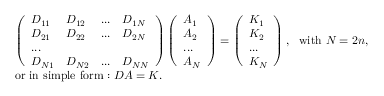<formula> <loc_0><loc_0><loc_500><loc_500>\begin{array} { r l } & { \left ( \begin{array} { l l l l } { D _ { 1 1 } } & { D _ { 1 2 } } & { \dots } & { D _ { 1 N } } \\ { D _ { 2 1 } } & { D _ { 2 2 } } & { \dots } & { D _ { 2 N } } \\ { \dots } \\ { D _ { N 1 } } & { D _ { N 2 } } & { \dots } & { D _ { N N } } \end{array} \right ) \left ( \begin{array} { l } { A _ { 1 } } \\ { A _ { 2 } } \\ { \dots } \\ { A _ { N } } \end{array} \right ) = \left ( \begin{array} { l } { K _ { 1 } } \\ { K _ { 2 } } \\ { \dots } \\ { K _ { N } } \end{array} \right ) , w i t h N = 2 n , } \\ & { o r i n s i m p l e f o r m \colon D A = K . } \end{array}</formula> 